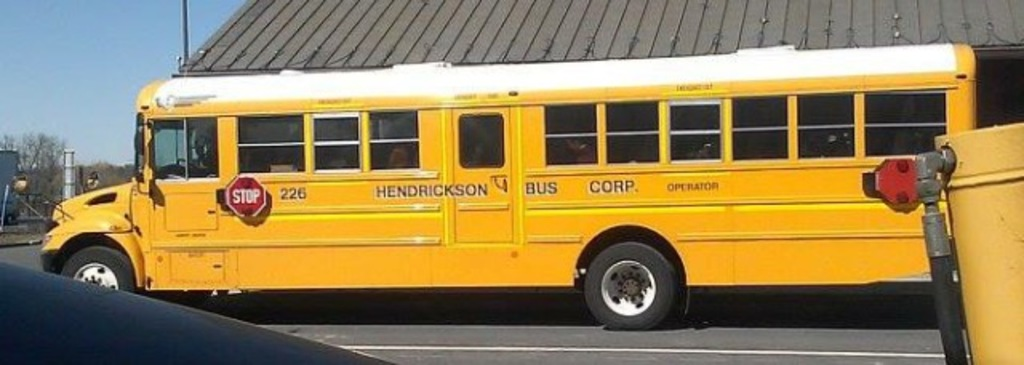Can you suggest any safety features visible on this school bus? The bus is equipped with a prominent red stop sign arm which is used while picking up or dropping off students to ensure safety. Additionally, the high visibility of its yellow color and reflective markings also enhance safety during its operations. 